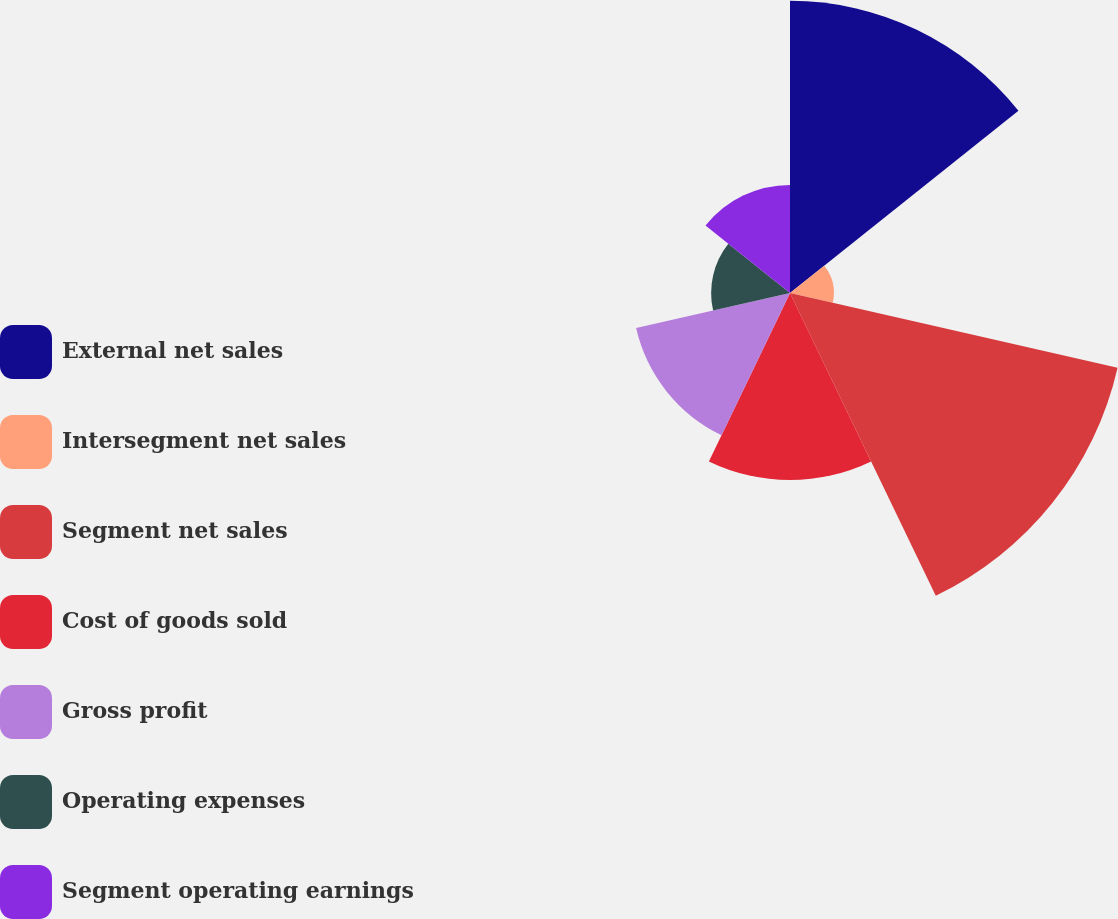<chart> <loc_0><loc_0><loc_500><loc_500><pie_chart><fcel>External net sales<fcel>Intersegment net sales<fcel>Segment net sales<fcel>Cost of goods sold<fcel>Gross profit<fcel>Operating expenses<fcel>Segment operating earnings<nl><fcel>24.27%<fcel>3.64%<fcel>27.91%<fcel>15.53%<fcel>13.11%<fcel>6.55%<fcel>8.98%<nl></chart> 